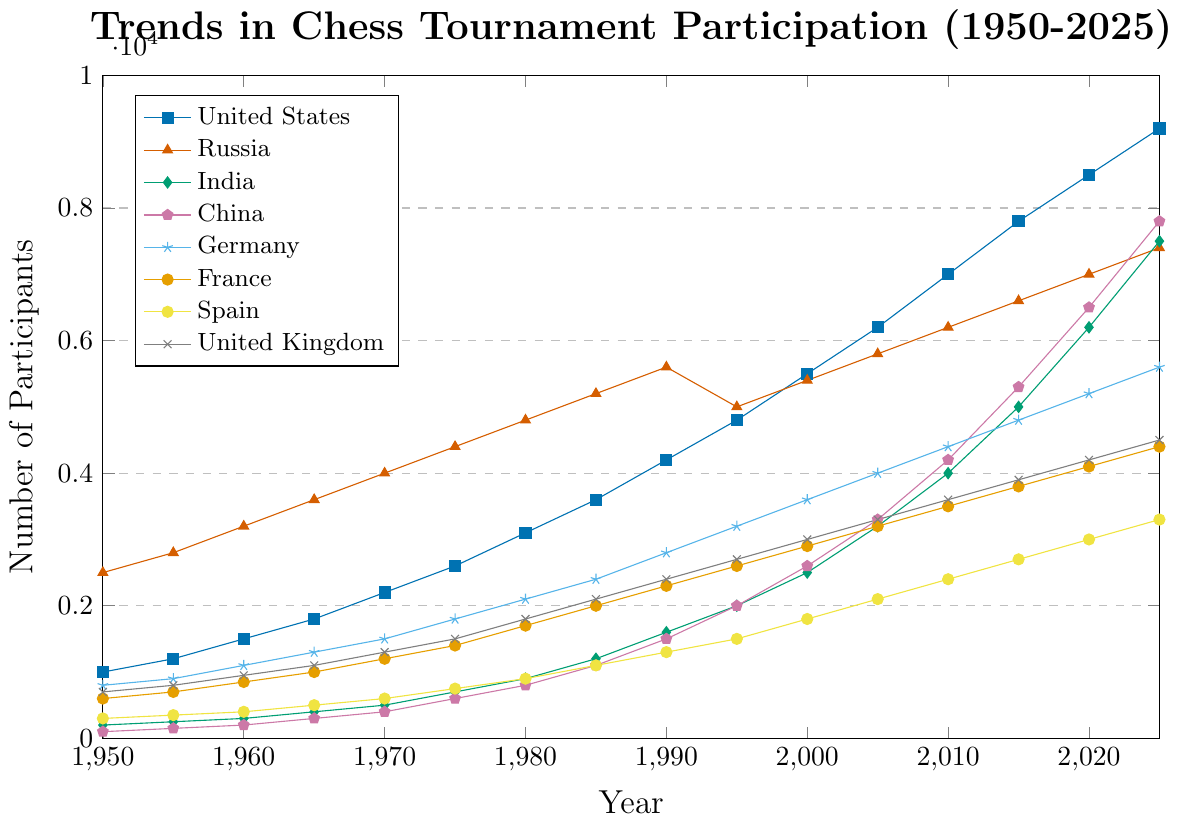Which country had the highest number of participants in 1970? Look at the peak values for each country in the year 1970 and compare them. Russia had the highest peak in 1970 with 4000 participants.
Answer: Russia What is the combined number of participants in the United States and India in 2025? Add the participants of both countries in 2025. United States has 9200 and India has 7500, so 9200 + 7500 = 16700.
Answer: 16700 Which country showed the greatest growth in participation between 1950 and 2025? Calculate the difference in the number of participants for each country between 1950 and 2025, then compare them. India grew from 200 to 7500, an increase of 7300, which is the highest growth.
Answer: India Is the participation trend in China higher or lower than that in Germany in 2020? Compare the values for China and Germany in the year 2020. China has 6500 and Germany has 5200; China’s trend is higher.
Answer: Higher How many countries had more than 5000 participants in 2025? Check the number of participants for each country in 2025 and count those with values exceeding 5000. United States, Russia, India, China, and Germany are the five countries that exceed 5000 participants.
Answer: 5 How does the number of participants in France in 1985 compare to the number of participants in Spain in 2000? Directly compare participants from both years. France had 2000 participants in 1985, and Spain had 1800 in 2000, indicating France had more.
Answer: France had more What are the average participants between 1990 and 2000 for the United Kingdom? Average participants over the given years: (2400+2700+3000)/3. Thus, (2400+2700+3000)/3 = 2700.
Answer: 2700 Which country had the smallest increase in participants from 1950 to 1975? Calculate the increase for each country and identify the smallest. China increased from 100 to 600, an increase of 500, which is the smallest.
Answer: China Compare the trends in participation for Russia and the United States from 2000 to 2025. Which country had a larger growth? Calculate the increase for both countries between 2000 to 2025. United States grew from 5500 to 9200 (increase of 3700), and Russia grew from 5400 to 7400 (increase of 2000). The United States had larger growth.
Answer: United States What year did Germany surpass 4000 participants? Identify the first year Germany had more than 4000 participants. Germany first surpassed 4000 participants in 2005 with exactly 4000.
Answer: 2005 